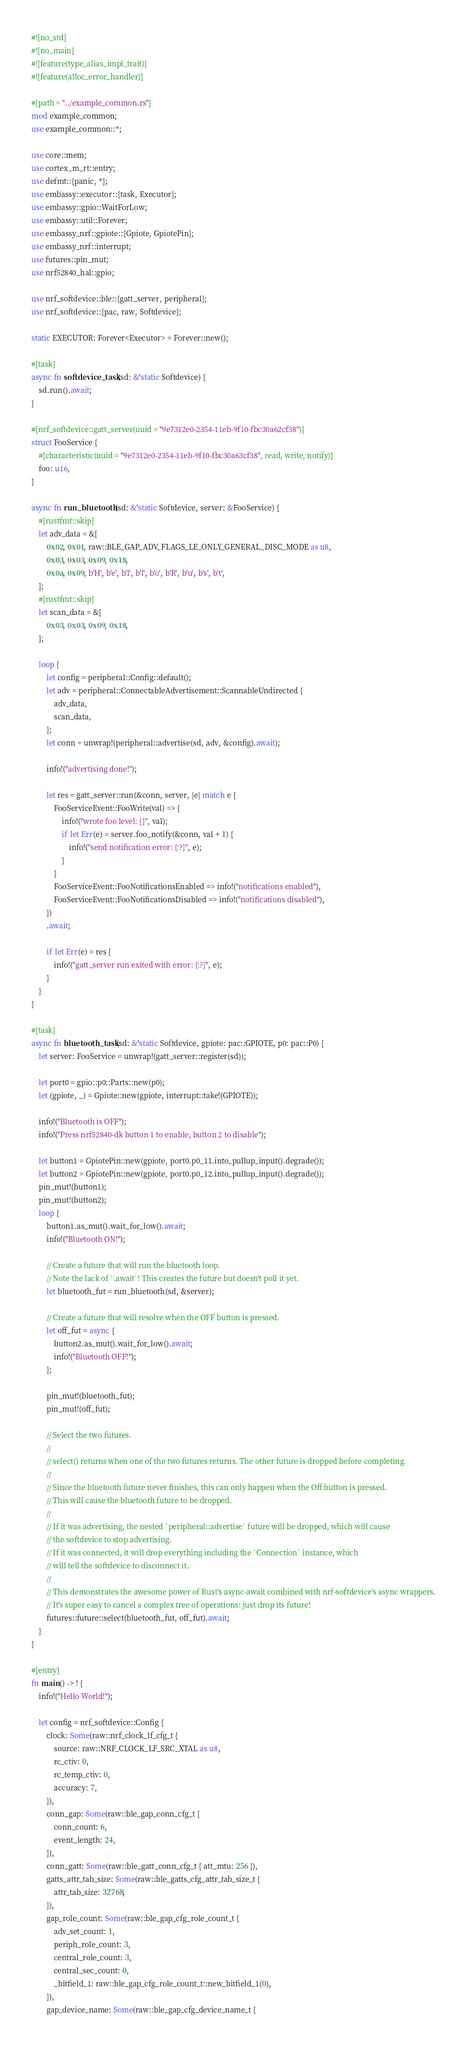<code> <loc_0><loc_0><loc_500><loc_500><_Rust_>#![no_std]
#![no_main]
#![feature(type_alias_impl_trait)]
#![feature(alloc_error_handler)]

#[path = "../example_common.rs"]
mod example_common;
use example_common::*;

use core::mem;
use cortex_m_rt::entry;
use defmt::{panic, *};
use embassy::executor::{task, Executor};
use embassy::gpio::WaitForLow;
use embassy::util::Forever;
use embassy_nrf::gpiote::{Gpiote, GpiotePin};
use embassy_nrf::interrupt;
use futures::pin_mut;
use nrf52840_hal::gpio;

use nrf_softdevice::ble::{gatt_server, peripheral};
use nrf_softdevice::{pac, raw, Softdevice};

static EXECUTOR: Forever<Executor> = Forever::new();

#[task]
async fn softdevice_task(sd: &'static Softdevice) {
    sd.run().await;
}

#[nrf_softdevice::gatt_server(uuid = "9e7312e0-2354-11eb-9f10-fbc30a62cf38")]
struct FooService {
    #[characteristic(uuid = "9e7312e0-2354-11eb-9f10-fbc30a63cf38", read, write, notify)]
    foo: u16,
}

async fn run_bluetooth(sd: &'static Softdevice, server: &FooService) {
    #[rustfmt::skip]
    let adv_data = &[
        0x02, 0x01, raw::BLE_GAP_ADV_FLAGS_LE_ONLY_GENERAL_DISC_MODE as u8,
        0x03, 0x03, 0x09, 0x18,
        0x0a, 0x09, b'H', b'e', b'l', b'l', b'o', b'R', b'u', b's', b't',
    ];
    #[rustfmt::skip]
    let scan_data = &[
        0x03, 0x03, 0x09, 0x18,
    ];

    loop {
        let config = peripheral::Config::default();
        let adv = peripheral::ConnectableAdvertisement::ScannableUndirected {
            adv_data,
            scan_data,
        };
        let conn = unwrap!(peripheral::advertise(sd, adv, &config).await);

        info!("advertising done!");

        let res = gatt_server::run(&conn, server, |e| match e {
            FooServiceEvent::FooWrite(val) => {
                info!("wrote foo level: {}", val);
                if let Err(e) = server.foo_notify(&conn, val + 1) {
                    info!("send notification error: {:?}", e);
                }
            }
            FooServiceEvent::FooNotificationsEnabled => info!("notifications enabled"),
            FooServiceEvent::FooNotificationsDisabled => info!("notifications disabled"),
        })
        .await;

        if let Err(e) = res {
            info!("gatt_server run exited with error: {:?}", e);
        }
    }
}

#[task]
async fn bluetooth_task(sd: &'static Softdevice, gpiote: pac::GPIOTE, p0: pac::P0) {
    let server: FooService = unwrap!(gatt_server::register(sd));

    let port0 = gpio::p0::Parts::new(p0);
    let (gpiote, _) = Gpiote::new(gpiote, interrupt::take!(GPIOTE));

    info!("Bluetooth is OFF");
    info!("Press nrf52840-dk button 1 to enable, button 2 to disable");

    let button1 = GpiotePin::new(gpiote, port0.p0_11.into_pullup_input().degrade());
    let button2 = GpiotePin::new(gpiote, port0.p0_12.into_pullup_input().degrade());
    pin_mut!(button1);
    pin_mut!(button2);
    loop {
        button1.as_mut().wait_for_low().await;
        info!("Bluetooth ON!");

        // Create a future that will run the bluetooth loop.
        // Note the lack of `.await`! This creates the future but doesn't poll it yet.
        let bluetooth_fut = run_bluetooth(sd, &server);

        // Create a future that will resolve when the OFF button is pressed.
        let off_fut = async {
            button2.as_mut().wait_for_low().await;
            info!("Bluetooth OFF!");
        };

        pin_mut!(bluetooth_fut);
        pin_mut!(off_fut);

        // Select the two futures.
        //
        // select() returns when one of the two futures returns. The other future is dropped before completing.
        //
        // Since the bluetooth future never finishes, this can only happen when the Off button is pressed.
        // This will cause the bluetooth future to be dropped.
        //
        // If it was advertising, the nested `peripheral::advertise` future will be dropped, which will cause
        // the softdevice to stop advertising.
        // If it was connected, it will drop everything including the `Connection` instance, which
        // will tell the softdevice to disconnect it.
        //
        // This demonstrates the awesome power of Rust's async-await combined with nrf-softdevice's async wrappers.
        // It's super easy to cancel a complex tree of operations: just drop its future!
        futures::future::select(bluetooth_fut, off_fut).await;
    }
}

#[entry]
fn main() -> ! {
    info!("Hello World!");

    let config = nrf_softdevice::Config {
        clock: Some(raw::nrf_clock_lf_cfg_t {
            source: raw::NRF_CLOCK_LF_SRC_XTAL as u8,
            rc_ctiv: 0,
            rc_temp_ctiv: 0,
            accuracy: 7,
        }),
        conn_gap: Some(raw::ble_gap_conn_cfg_t {
            conn_count: 6,
            event_length: 24,
        }),
        conn_gatt: Some(raw::ble_gatt_conn_cfg_t { att_mtu: 256 }),
        gatts_attr_tab_size: Some(raw::ble_gatts_cfg_attr_tab_size_t {
            attr_tab_size: 32768,
        }),
        gap_role_count: Some(raw::ble_gap_cfg_role_count_t {
            adv_set_count: 1,
            periph_role_count: 3,
            central_role_count: 3,
            central_sec_count: 0,
            _bitfield_1: raw::ble_gap_cfg_role_count_t::new_bitfield_1(0),
        }),
        gap_device_name: Some(raw::ble_gap_cfg_device_name_t {</code> 